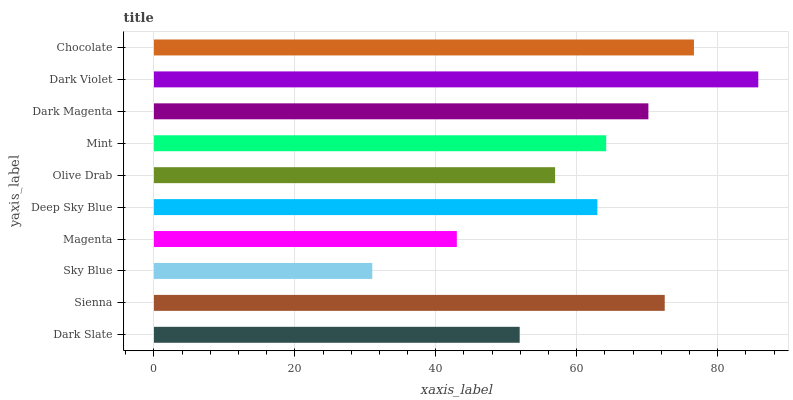Is Sky Blue the minimum?
Answer yes or no. Yes. Is Dark Violet the maximum?
Answer yes or no. Yes. Is Sienna the minimum?
Answer yes or no. No. Is Sienna the maximum?
Answer yes or no. No. Is Sienna greater than Dark Slate?
Answer yes or no. Yes. Is Dark Slate less than Sienna?
Answer yes or no. Yes. Is Dark Slate greater than Sienna?
Answer yes or no. No. Is Sienna less than Dark Slate?
Answer yes or no. No. Is Mint the high median?
Answer yes or no. Yes. Is Deep Sky Blue the low median?
Answer yes or no. Yes. Is Olive Drab the high median?
Answer yes or no. No. Is Olive Drab the low median?
Answer yes or no. No. 